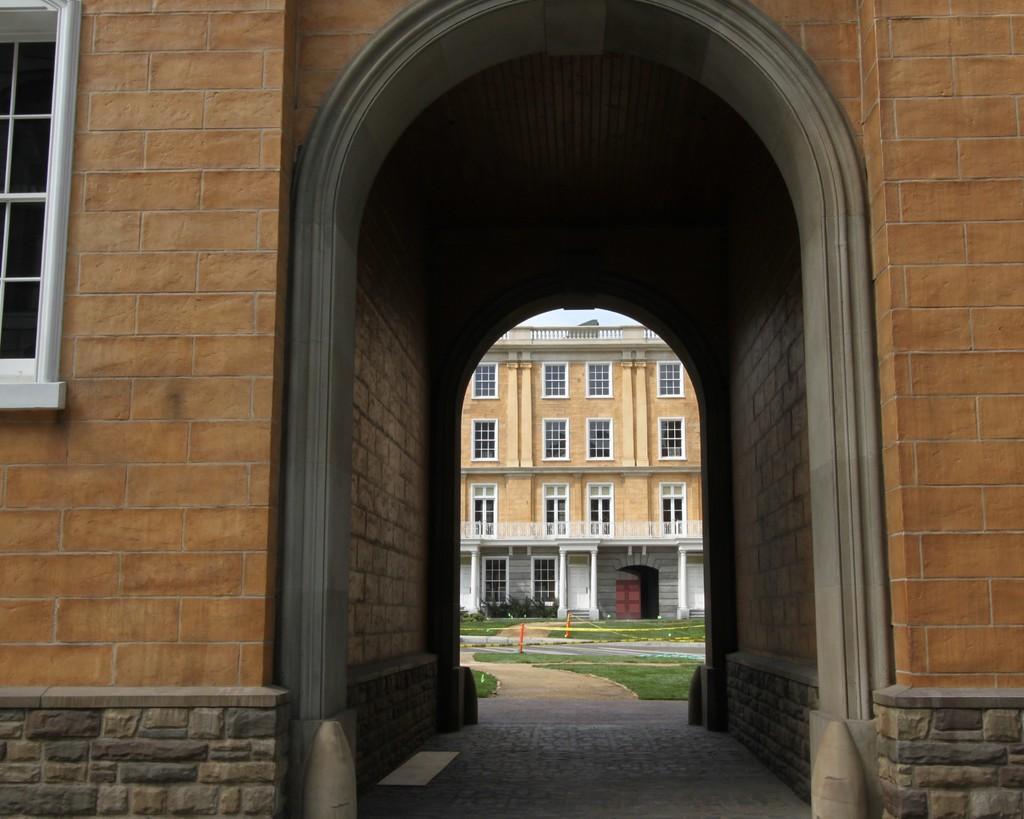How would you summarize this image in a sentence or two? In this picture we can see few buildings and grass. 